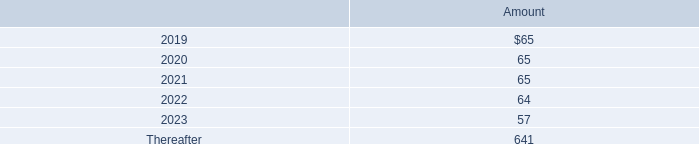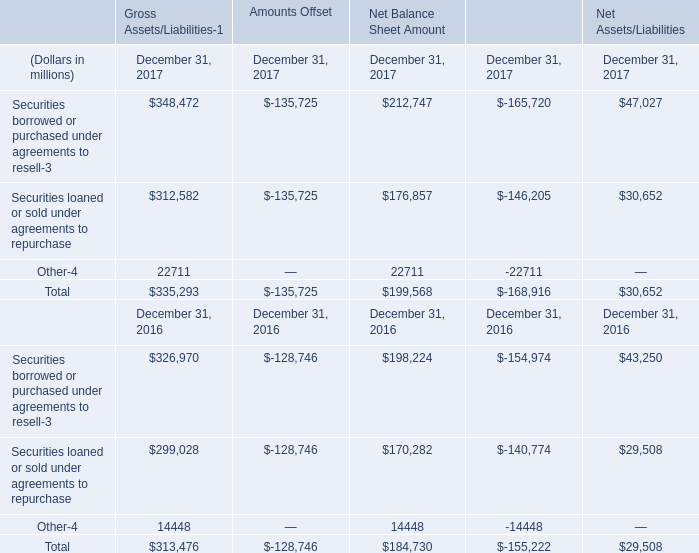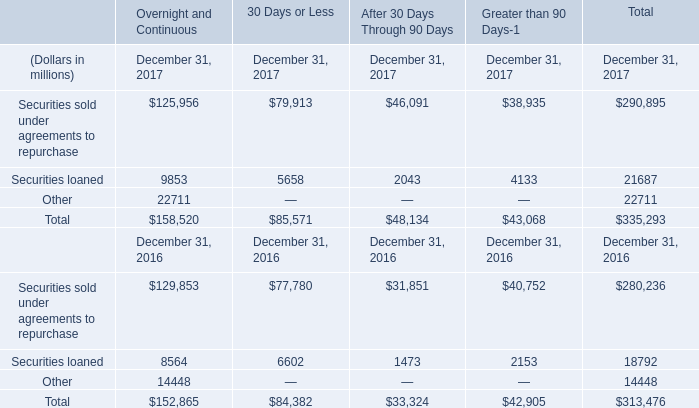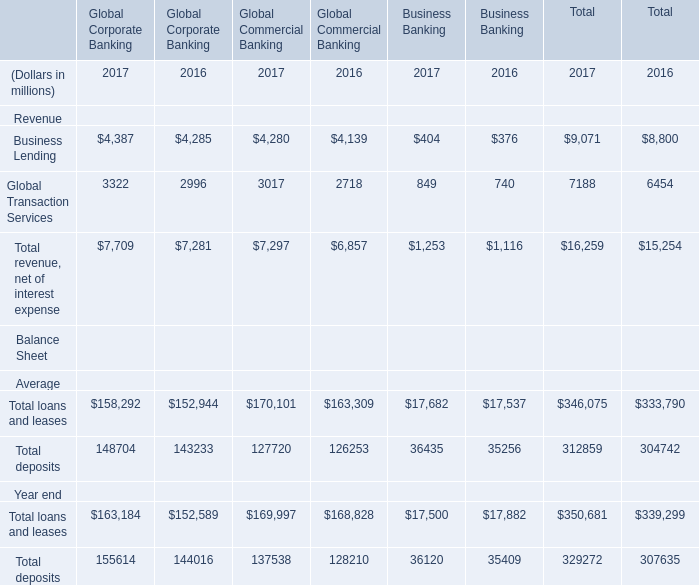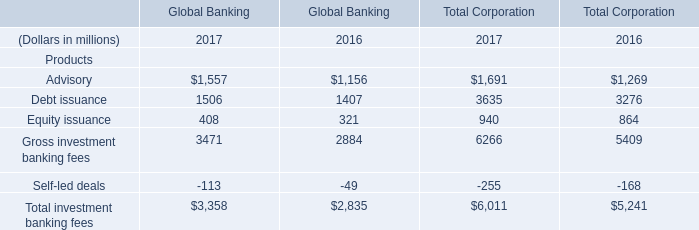What's the sum of Other of Financial Instruments December 31, 2017, Global Transaction Services of Global Commercial Banking 2017, and Securities loaned of After 30 Days Through 90 Days December 31, 2017 ? 
Computations: ((22711.0 + 3017.0) + 2043.0)
Answer: 27771.0. 